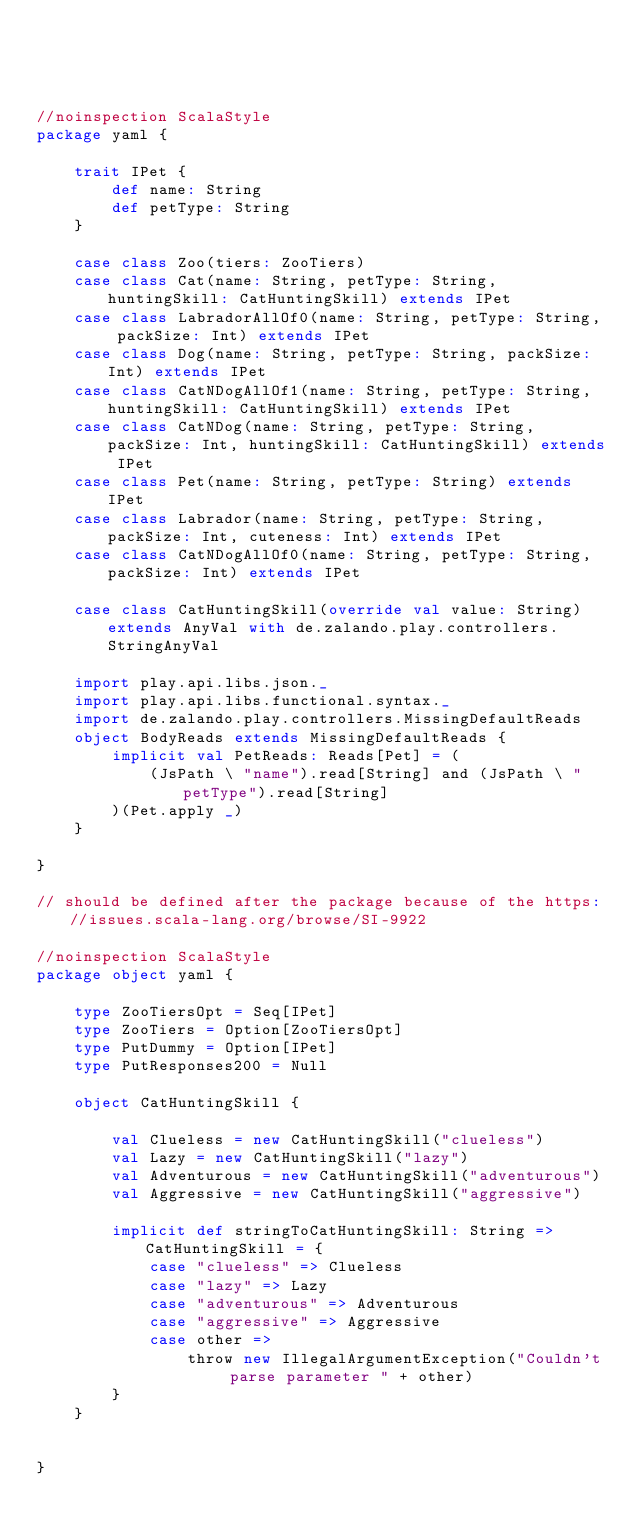<code> <loc_0><loc_0><loc_500><loc_500><_Scala_>



//noinspection ScalaStyle
package yaml {

    trait IPet {
        def name: String
        def petType: String
    }

    case class Zoo(tiers: ZooTiers) 
    case class Cat(name: String, petType: String, huntingSkill: CatHuntingSkill) extends IPet
    case class LabradorAllOf0(name: String, petType: String, packSize: Int) extends IPet
    case class Dog(name: String, petType: String, packSize: Int) extends IPet
    case class CatNDogAllOf1(name: String, petType: String, huntingSkill: CatHuntingSkill) extends IPet
    case class CatNDog(name: String, petType: String, packSize: Int, huntingSkill: CatHuntingSkill) extends IPet
    case class Pet(name: String, petType: String) extends IPet
    case class Labrador(name: String, petType: String, packSize: Int, cuteness: Int) extends IPet
    case class CatNDogAllOf0(name: String, petType: String, packSize: Int) extends IPet

    case class CatHuntingSkill(override val value: String) extends AnyVal with de.zalando.play.controllers.StringAnyVal

    import play.api.libs.json._
    import play.api.libs.functional.syntax._
    import de.zalando.play.controllers.MissingDefaultReads
    object BodyReads extends MissingDefaultReads {
        implicit val PetReads: Reads[Pet] = (
            (JsPath \ "name").read[String] and (JsPath \ "petType").read[String]
        )(Pet.apply _)
    }

}

// should be defined after the package because of the https://issues.scala-lang.org/browse/SI-9922

//noinspection ScalaStyle
package object yaml {

    type ZooTiersOpt = Seq[IPet]
    type ZooTiers = Option[ZooTiersOpt]
    type PutDummy = Option[IPet]
    type PutResponses200 = Null

    object CatHuntingSkill {
        
        val Clueless = new CatHuntingSkill("clueless")
        val Lazy = new CatHuntingSkill("lazy")
        val Adventurous = new CatHuntingSkill("adventurous")
        val Aggressive = new CatHuntingSkill("aggressive")

        implicit def stringToCatHuntingSkill: String => CatHuntingSkill = {
            case "clueless" => Clueless
            case "lazy" => Lazy
            case "adventurous" => Adventurous
            case "aggressive" => Aggressive
            case other =>
                throw new IllegalArgumentException("Couldn't parse parameter " + other)
        }
    }


}</code> 